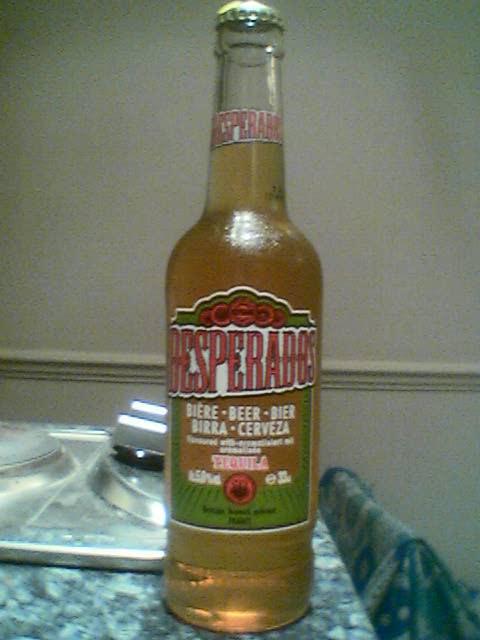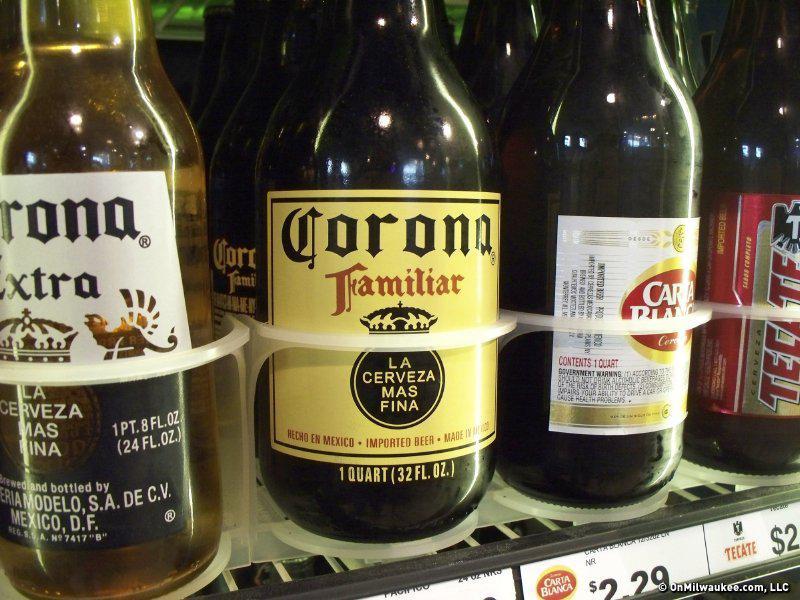The first image is the image on the left, the second image is the image on the right. Given the left and right images, does the statement "There are exactly two bottles in one of the images." hold true? Answer yes or no. No. The first image is the image on the left, the second image is the image on the right. Analyze the images presented: Is the assertion "One image contains exactly two brown glass beer bottles standing on a table, and no image contains more than three glass bottles." valid? Answer yes or no. No. 